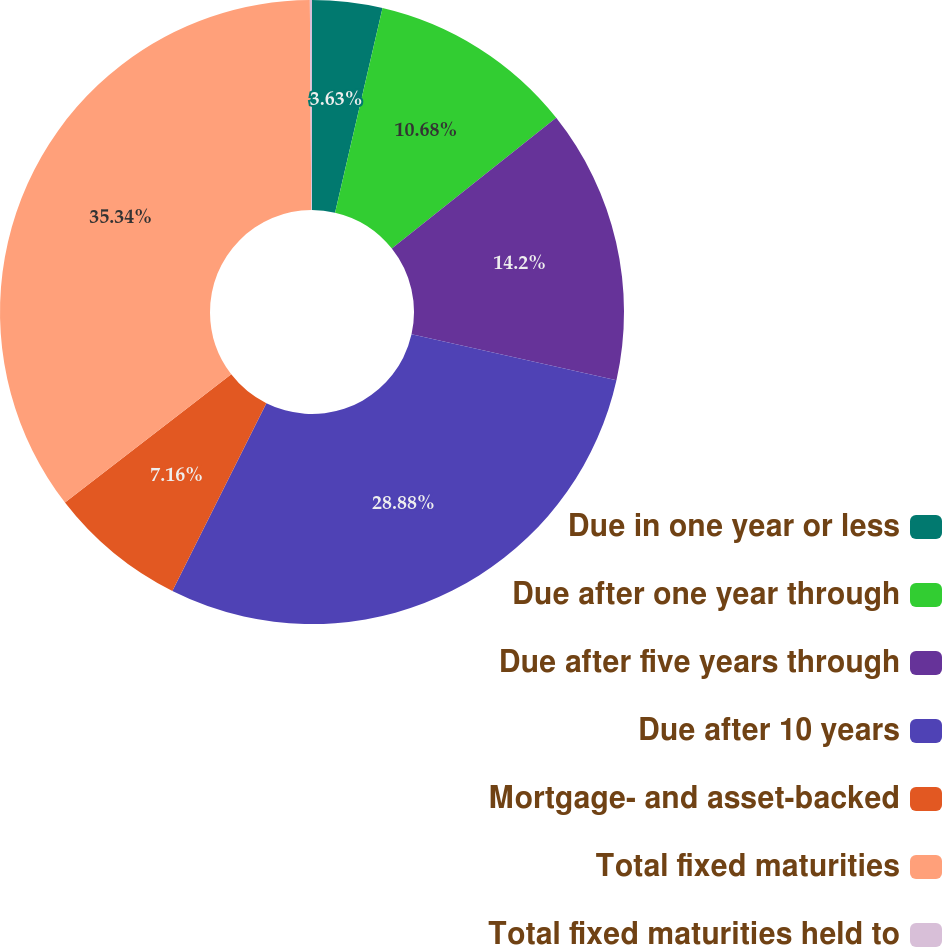Convert chart to OTSL. <chart><loc_0><loc_0><loc_500><loc_500><pie_chart><fcel>Due in one year or less<fcel>Due after one year through<fcel>Due after five years through<fcel>Due after 10 years<fcel>Mortgage- and asset-backed<fcel>Total fixed maturities<fcel>Total fixed maturities held to<nl><fcel>3.63%<fcel>10.68%<fcel>14.2%<fcel>28.88%<fcel>7.16%<fcel>35.35%<fcel>0.11%<nl></chart> 